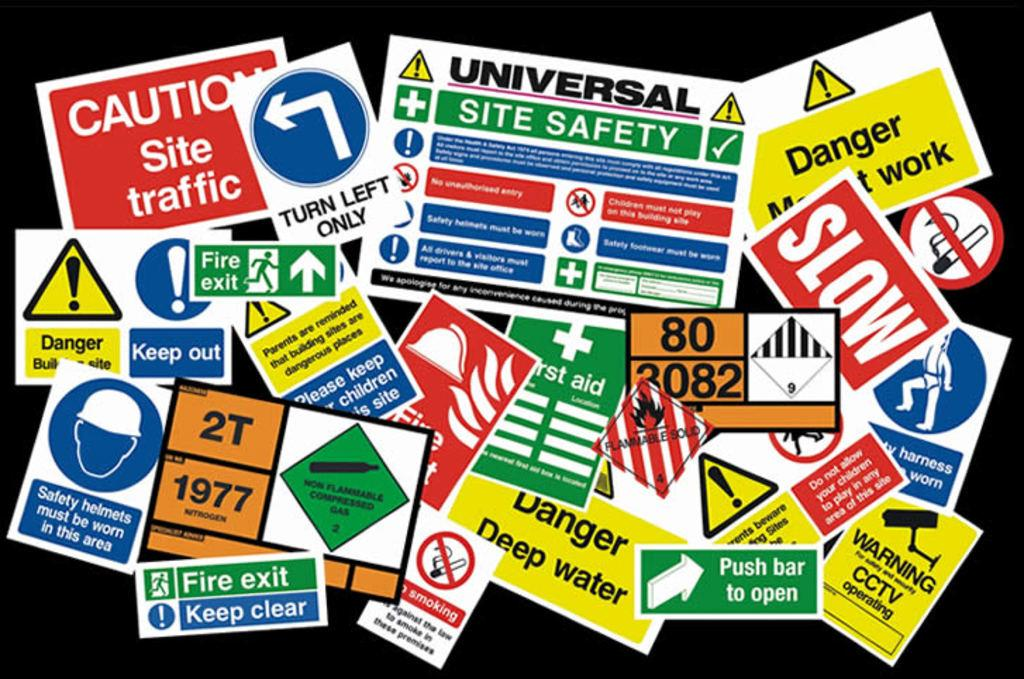<image>
Present a compact description of the photo's key features. A bunch of stickers one says to push bar to open. 